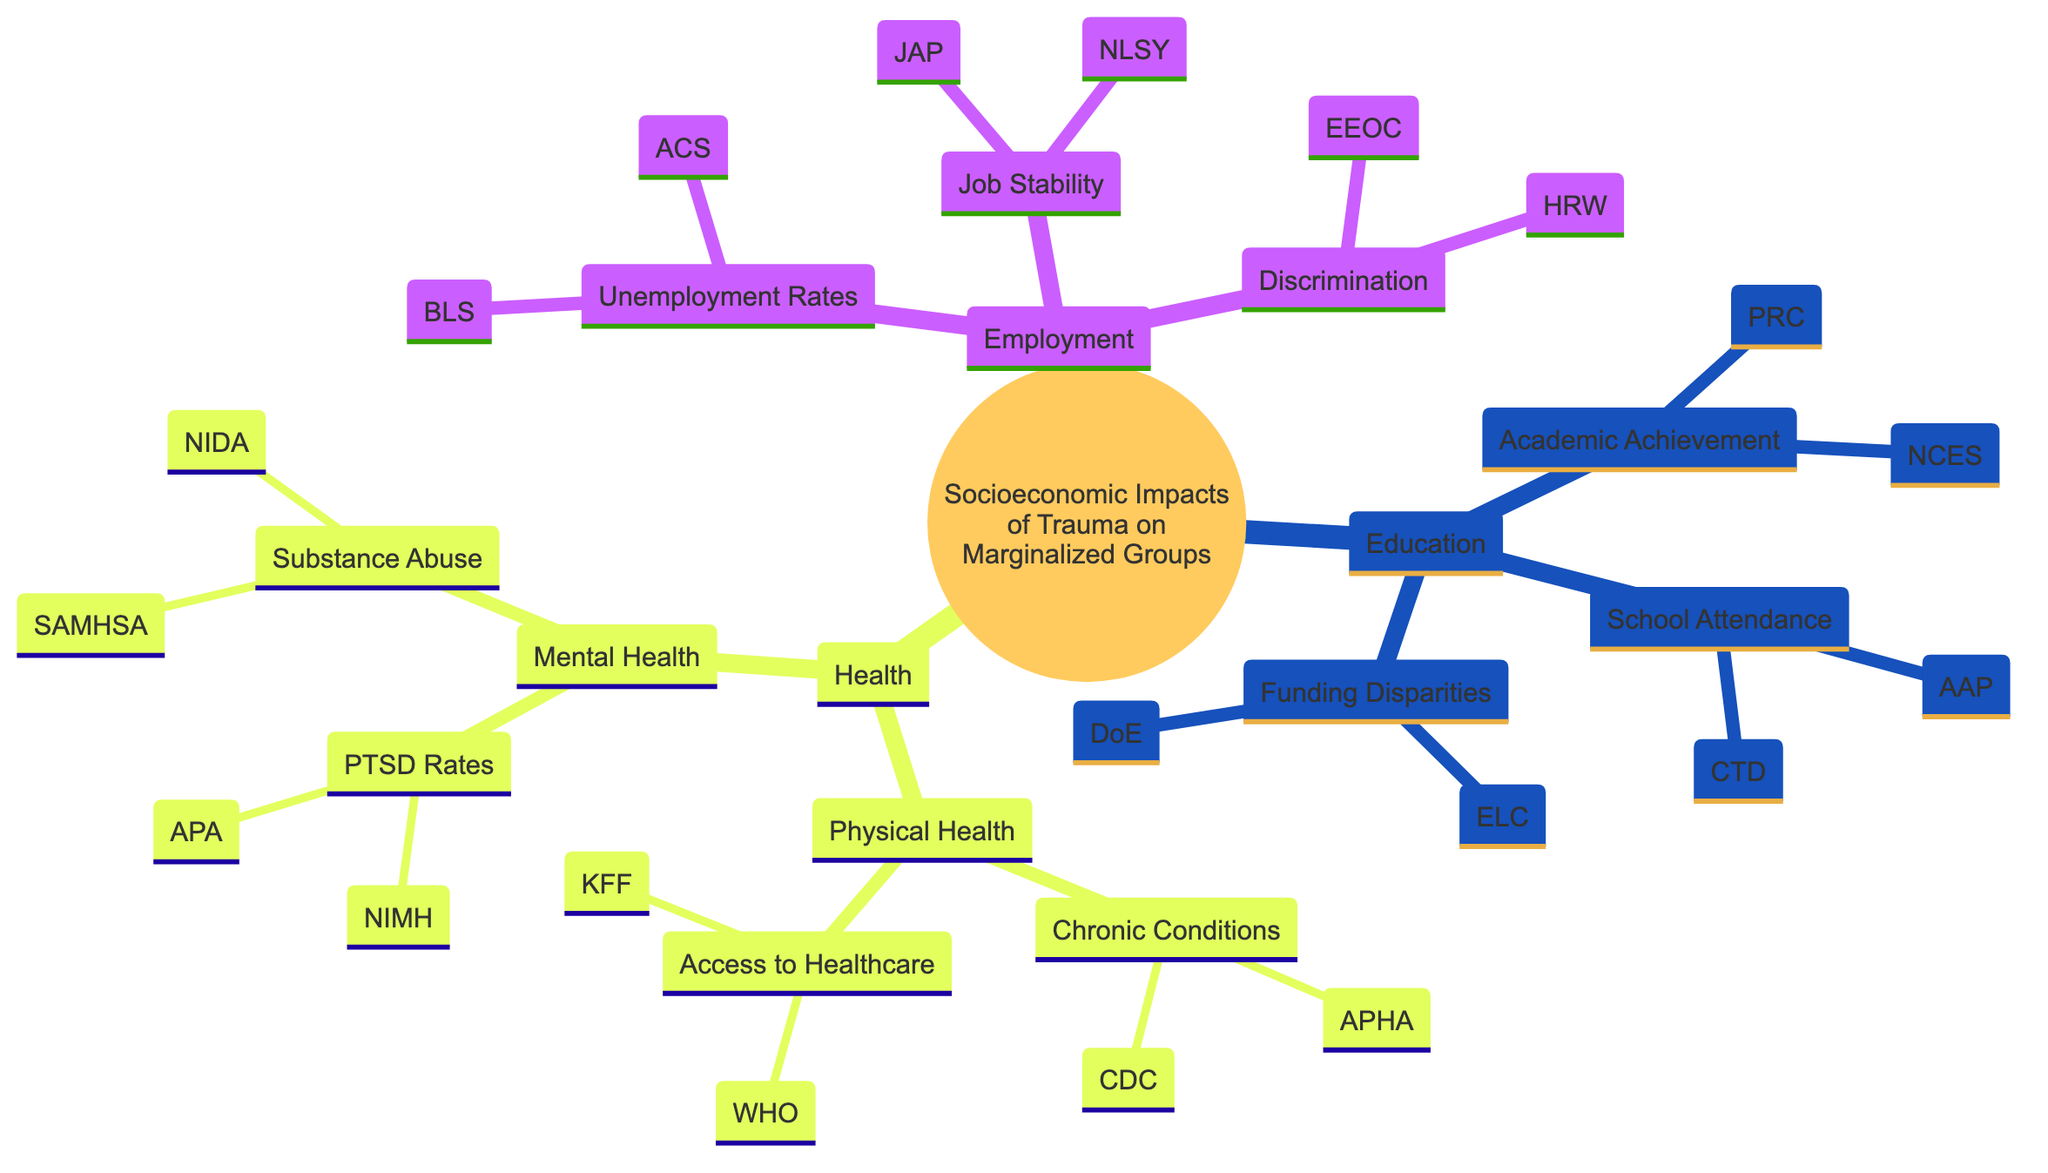What are the three main categories discussed in this mind map? The mind map has three main categories: Employment, Education, and Health. Each of these categories encompasses various subtopics related to the socioeconomic impacts of trauma on marginalized groups.
Answer: Employment, Education, Health How many sources are listed under Employment? Under the Employment category, there are 6 sources indicated: Bureau of Labor Statistics, American Community Survey, Journal of Applied Psychology, National Longitudinal Survey of Youth, EEOC Charge Statistics, and Human Rights Watch. Adding these together gives a total of 6 sources.
Answer: 6 What is the relationship between trauma and job stability? The mind map shows that trauma negatively impacts job retention and career progression, indicating a detrimental relationship between trauma and job stability.
Answer: Negative impact What descriptive report sources are associated with School Attendance? The sources associated with School Attendance are the Child Trends Database and the American Academy of Pediatrics, which provide insights into the impact of trauma on school attendance and dropout rates.
Answer: Child Trends Database, American Academy of Pediatrics What type of health conditions are more prevalent among trauma-affected individuals? The mind map states that trauma-affected individuals have a higher prevalence of chronic conditions, highlighting physical health challenges faced by these communities.
Answer: Chronic conditions Which two organizations provide data on PTSD rates in marginalized communities? The National Institute of Mental Health and the American Psychological Association are the two organizations listed that provide data on PTSD rates specifically within marginalized communities.
Answer: National Institute of Mental Health, American Psychological Association How does trauma impact educational achievement according to the diagram? The diagram indicates that there is a correlation between trauma and lower educational attainment, suggesting that trauma adversely affects academic success and achievement.
Answer: Correlation with lower attainment What evidence supports the claim that trauma affects access to healthcare? The mind map references reports from the Kaiser Family Foundation and the World Health Organization, which present information on the barriers faced by marginalized communities in accessing healthcare services.
Answer: Kaiser Family Foundation, World Health Organization What effect does trauma have on substance abuse rates according to the mind map? The mind map describes a correlation between trauma and increased substance abuse rates, indicating that those affected by trauma are more likely to struggle with substance abuse issues.
Answer: Correlation with increased rates 